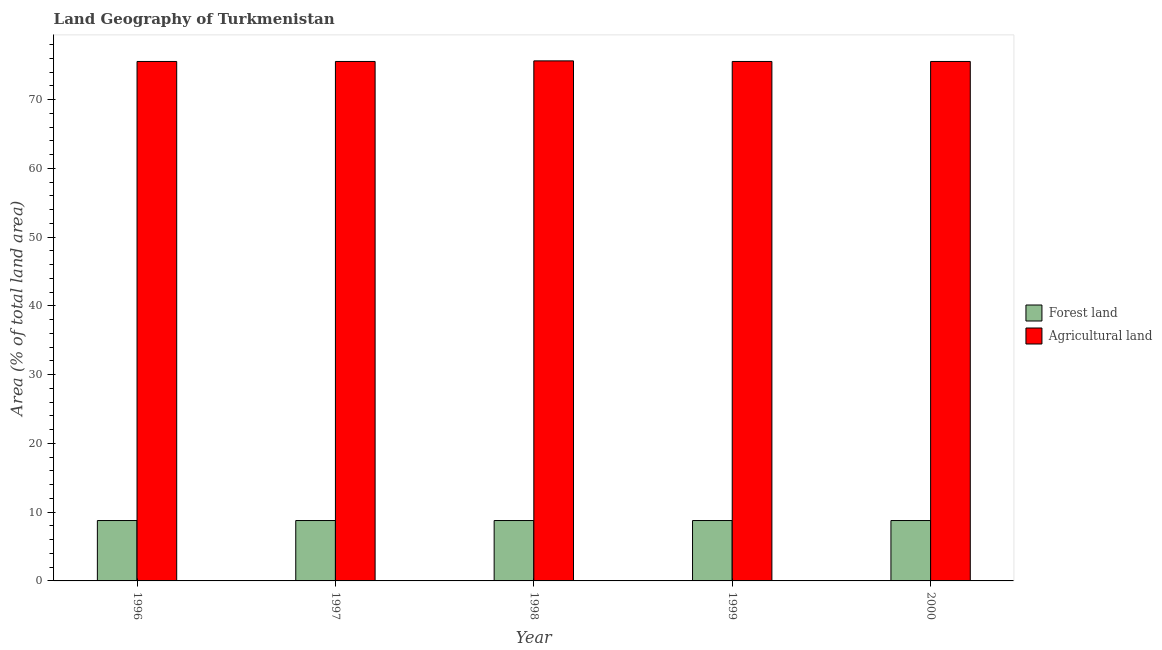How many different coloured bars are there?
Provide a short and direct response. 2. How many groups of bars are there?
Give a very brief answer. 5. Are the number of bars on each tick of the X-axis equal?
Your answer should be very brief. Yes. How many bars are there on the 1st tick from the left?
Make the answer very short. 2. In how many cases, is the number of bars for a given year not equal to the number of legend labels?
Provide a short and direct response. 0. What is the percentage of land area under agriculture in 1996?
Give a very brief answer. 75.54. Across all years, what is the maximum percentage of land area under forests?
Your response must be concise. 8.78. Across all years, what is the minimum percentage of land area under agriculture?
Provide a succinct answer. 75.54. What is the total percentage of land area under agriculture in the graph?
Offer a terse response. 377.8. What is the difference between the percentage of land area under forests in 1997 and the percentage of land area under agriculture in 1996?
Offer a terse response. 0. What is the average percentage of land area under forests per year?
Offer a terse response. 8.78. In how many years, is the percentage of land area under forests greater than 12 %?
Offer a terse response. 0. What is the ratio of the percentage of land area under agriculture in 1996 to that in 1998?
Ensure brevity in your answer.  1. Is the percentage of land area under forests in 1997 less than that in 1998?
Provide a succinct answer. No. What is the difference between the highest and the second highest percentage of land area under forests?
Make the answer very short. 0. What is the difference between the highest and the lowest percentage of land area under agriculture?
Your answer should be compact. 0.09. What does the 2nd bar from the left in 1999 represents?
Provide a short and direct response. Agricultural land. What does the 1st bar from the right in 1999 represents?
Provide a succinct answer. Agricultural land. How many bars are there?
Provide a succinct answer. 10. Are all the bars in the graph horizontal?
Provide a succinct answer. No. Are the values on the major ticks of Y-axis written in scientific E-notation?
Offer a very short reply. No. Does the graph contain any zero values?
Your response must be concise. No. What is the title of the graph?
Your response must be concise. Land Geography of Turkmenistan. Does "% of GNI" appear as one of the legend labels in the graph?
Keep it short and to the point. No. What is the label or title of the Y-axis?
Offer a terse response. Area (% of total land area). What is the Area (% of total land area) of Forest land in 1996?
Provide a short and direct response. 8.78. What is the Area (% of total land area) of Agricultural land in 1996?
Keep it short and to the point. 75.54. What is the Area (% of total land area) of Forest land in 1997?
Make the answer very short. 8.78. What is the Area (% of total land area) of Agricultural land in 1997?
Make the answer very short. 75.54. What is the Area (% of total land area) of Forest land in 1998?
Keep it short and to the point. 8.78. What is the Area (% of total land area) in Agricultural land in 1998?
Your answer should be compact. 75.63. What is the Area (% of total land area) of Forest land in 1999?
Ensure brevity in your answer.  8.78. What is the Area (% of total land area) of Agricultural land in 1999?
Give a very brief answer. 75.54. What is the Area (% of total land area) in Forest land in 2000?
Ensure brevity in your answer.  8.78. What is the Area (% of total land area) of Agricultural land in 2000?
Your answer should be very brief. 75.54. Across all years, what is the maximum Area (% of total land area) of Forest land?
Provide a succinct answer. 8.78. Across all years, what is the maximum Area (% of total land area) of Agricultural land?
Keep it short and to the point. 75.63. Across all years, what is the minimum Area (% of total land area) in Forest land?
Give a very brief answer. 8.78. Across all years, what is the minimum Area (% of total land area) of Agricultural land?
Offer a very short reply. 75.54. What is the total Area (% of total land area) of Forest land in the graph?
Your answer should be compact. 43.91. What is the total Area (% of total land area) in Agricultural land in the graph?
Ensure brevity in your answer.  377.8. What is the difference between the Area (% of total land area) in Agricultural land in 1996 and that in 1997?
Provide a short and direct response. 0. What is the difference between the Area (% of total land area) of Agricultural land in 1996 and that in 1998?
Give a very brief answer. -0.09. What is the difference between the Area (% of total land area) in Agricultural land in 1996 and that in 2000?
Offer a very short reply. 0. What is the difference between the Area (% of total land area) in Agricultural land in 1997 and that in 1998?
Offer a very short reply. -0.09. What is the difference between the Area (% of total land area) of Agricultural land in 1997 and that in 1999?
Offer a very short reply. 0. What is the difference between the Area (% of total land area) of Forest land in 1997 and that in 2000?
Your answer should be compact. 0. What is the difference between the Area (% of total land area) of Agricultural land in 1997 and that in 2000?
Ensure brevity in your answer.  0. What is the difference between the Area (% of total land area) of Forest land in 1998 and that in 1999?
Your answer should be compact. 0. What is the difference between the Area (% of total land area) in Agricultural land in 1998 and that in 1999?
Ensure brevity in your answer.  0.09. What is the difference between the Area (% of total land area) of Agricultural land in 1998 and that in 2000?
Give a very brief answer. 0.09. What is the difference between the Area (% of total land area) in Forest land in 1996 and the Area (% of total land area) in Agricultural land in 1997?
Ensure brevity in your answer.  -66.76. What is the difference between the Area (% of total land area) in Forest land in 1996 and the Area (% of total land area) in Agricultural land in 1998?
Your response must be concise. -66.85. What is the difference between the Area (% of total land area) of Forest land in 1996 and the Area (% of total land area) of Agricultural land in 1999?
Provide a short and direct response. -66.76. What is the difference between the Area (% of total land area) in Forest land in 1996 and the Area (% of total land area) in Agricultural land in 2000?
Ensure brevity in your answer.  -66.76. What is the difference between the Area (% of total land area) in Forest land in 1997 and the Area (% of total land area) in Agricultural land in 1998?
Your answer should be compact. -66.85. What is the difference between the Area (% of total land area) of Forest land in 1997 and the Area (% of total land area) of Agricultural land in 1999?
Make the answer very short. -66.76. What is the difference between the Area (% of total land area) in Forest land in 1997 and the Area (% of total land area) in Agricultural land in 2000?
Provide a short and direct response. -66.76. What is the difference between the Area (% of total land area) in Forest land in 1998 and the Area (% of total land area) in Agricultural land in 1999?
Offer a very short reply. -66.76. What is the difference between the Area (% of total land area) of Forest land in 1998 and the Area (% of total land area) of Agricultural land in 2000?
Provide a short and direct response. -66.76. What is the difference between the Area (% of total land area) of Forest land in 1999 and the Area (% of total land area) of Agricultural land in 2000?
Provide a succinct answer. -66.76. What is the average Area (% of total land area) of Forest land per year?
Provide a succinct answer. 8.78. What is the average Area (% of total land area) in Agricultural land per year?
Make the answer very short. 75.56. In the year 1996, what is the difference between the Area (% of total land area) in Forest land and Area (% of total land area) in Agricultural land?
Give a very brief answer. -66.76. In the year 1997, what is the difference between the Area (% of total land area) of Forest land and Area (% of total land area) of Agricultural land?
Keep it short and to the point. -66.76. In the year 1998, what is the difference between the Area (% of total land area) in Forest land and Area (% of total land area) in Agricultural land?
Keep it short and to the point. -66.85. In the year 1999, what is the difference between the Area (% of total land area) of Forest land and Area (% of total land area) of Agricultural land?
Provide a short and direct response. -66.76. In the year 2000, what is the difference between the Area (% of total land area) in Forest land and Area (% of total land area) in Agricultural land?
Provide a succinct answer. -66.76. What is the ratio of the Area (% of total land area) of Agricultural land in 1996 to that in 1997?
Your response must be concise. 1. What is the ratio of the Area (% of total land area) in Forest land in 1996 to that in 1998?
Provide a short and direct response. 1. What is the ratio of the Area (% of total land area) in Forest land in 1996 to that in 2000?
Offer a very short reply. 1. What is the ratio of the Area (% of total land area) of Forest land in 1997 to that in 1998?
Give a very brief answer. 1. What is the ratio of the Area (% of total land area) in Agricultural land in 1997 to that in 1998?
Your answer should be compact. 1. What is the ratio of the Area (% of total land area) of Forest land in 1997 to that in 1999?
Your answer should be compact. 1. What is the ratio of the Area (% of total land area) of Agricultural land in 1997 to that in 2000?
Provide a short and direct response. 1. What is the ratio of the Area (% of total land area) of Forest land in 1998 to that in 1999?
Ensure brevity in your answer.  1. What is the ratio of the Area (% of total land area) of Forest land in 1999 to that in 2000?
Provide a short and direct response. 1. What is the difference between the highest and the second highest Area (% of total land area) of Agricultural land?
Give a very brief answer. 0.09. What is the difference between the highest and the lowest Area (% of total land area) of Agricultural land?
Offer a very short reply. 0.09. 